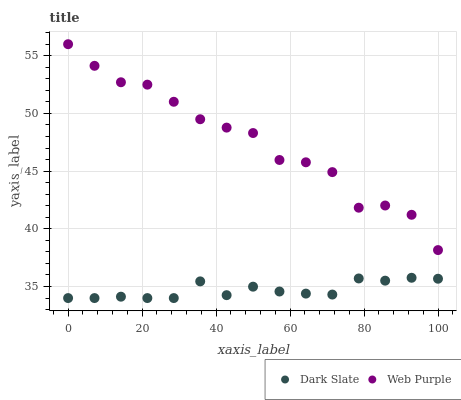Does Dark Slate have the minimum area under the curve?
Answer yes or no. Yes. Does Web Purple have the maximum area under the curve?
Answer yes or no. Yes. Does Web Purple have the minimum area under the curve?
Answer yes or no. No. Is Dark Slate the smoothest?
Answer yes or no. Yes. Is Web Purple the roughest?
Answer yes or no. Yes. Is Web Purple the smoothest?
Answer yes or no. No. Does Dark Slate have the lowest value?
Answer yes or no. Yes. Does Web Purple have the lowest value?
Answer yes or no. No. Does Web Purple have the highest value?
Answer yes or no. Yes. Is Dark Slate less than Web Purple?
Answer yes or no. Yes. Is Web Purple greater than Dark Slate?
Answer yes or no. Yes. Does Dark Slate intersect Web Purple?
Answer yes or no. No. 